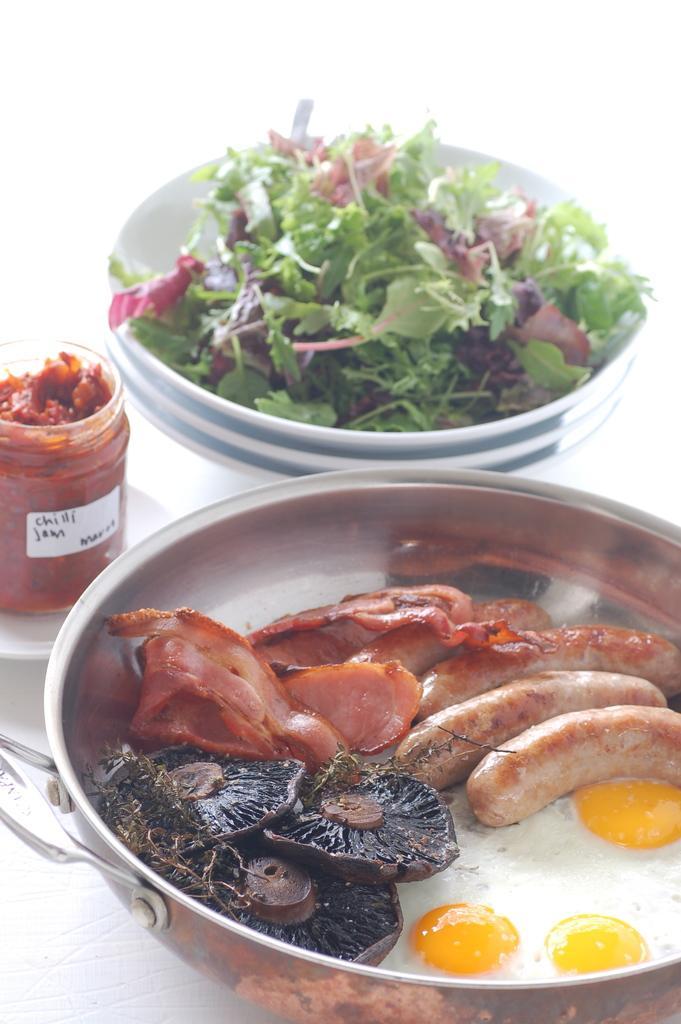Please provide a concise description of this image. Here in this picture we can see a table, on which we can see a pan having meat, half boiled eggs and sausages present over there and beside that we can see bowls with some leafy vegetables present over there and on the left side we can see a container with pickle over there. 